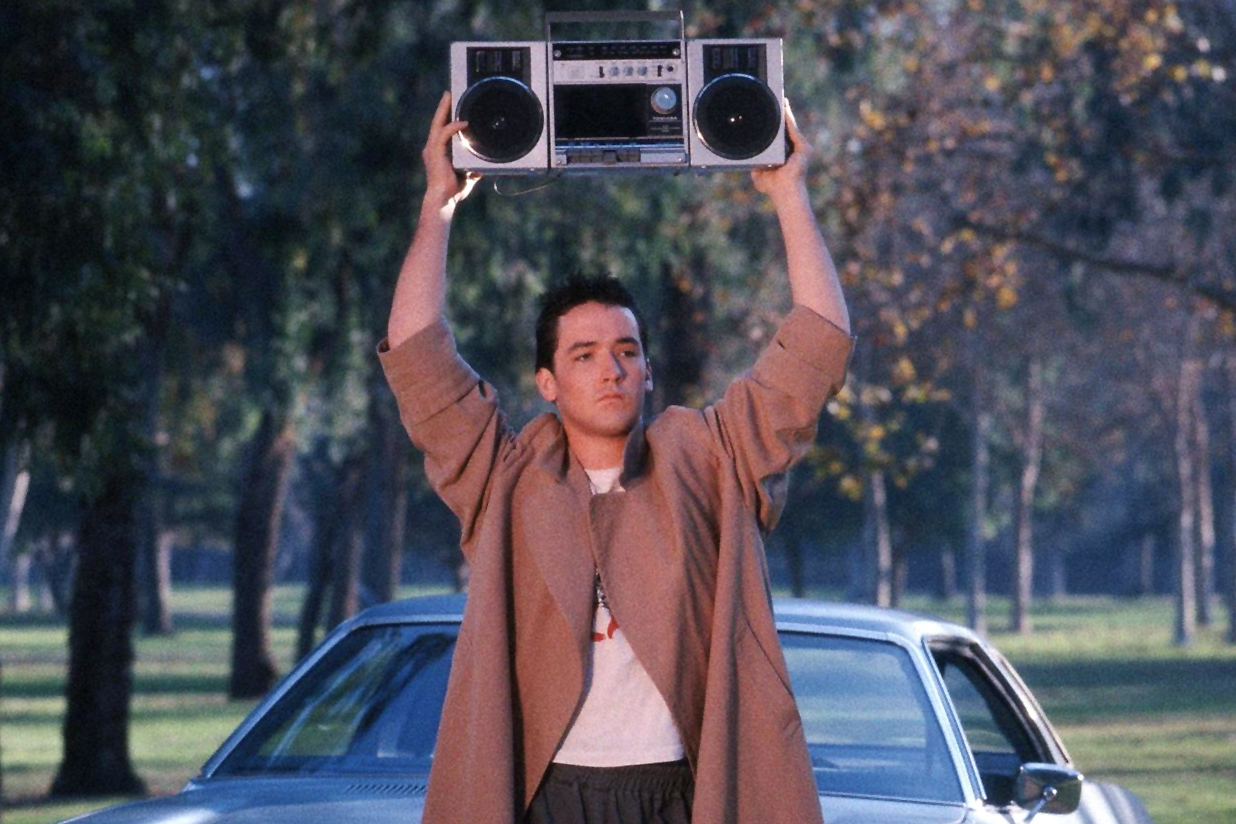If Lloyd Dobler were a superhero, what would his superpower be based on this scene? If Lloyd Dobler were a superhero, based on this scene, his superpower would be the ability to amplify emotions and communicate directly through music. Imagine him as 'The Harmonizer,' a hero who can project powerful waves of emotion through sound, using his boombox as a conduit. The music he plays can soothe conflict, inspire courage, and create deep emotional connections between people. In this scene, holding the boombox aloft, he channels his determination and love into a transformative force that can break down barriers and unify hearts. His power transcends physical strength, showcasing the profound impact that art and emotion can have on the world. 